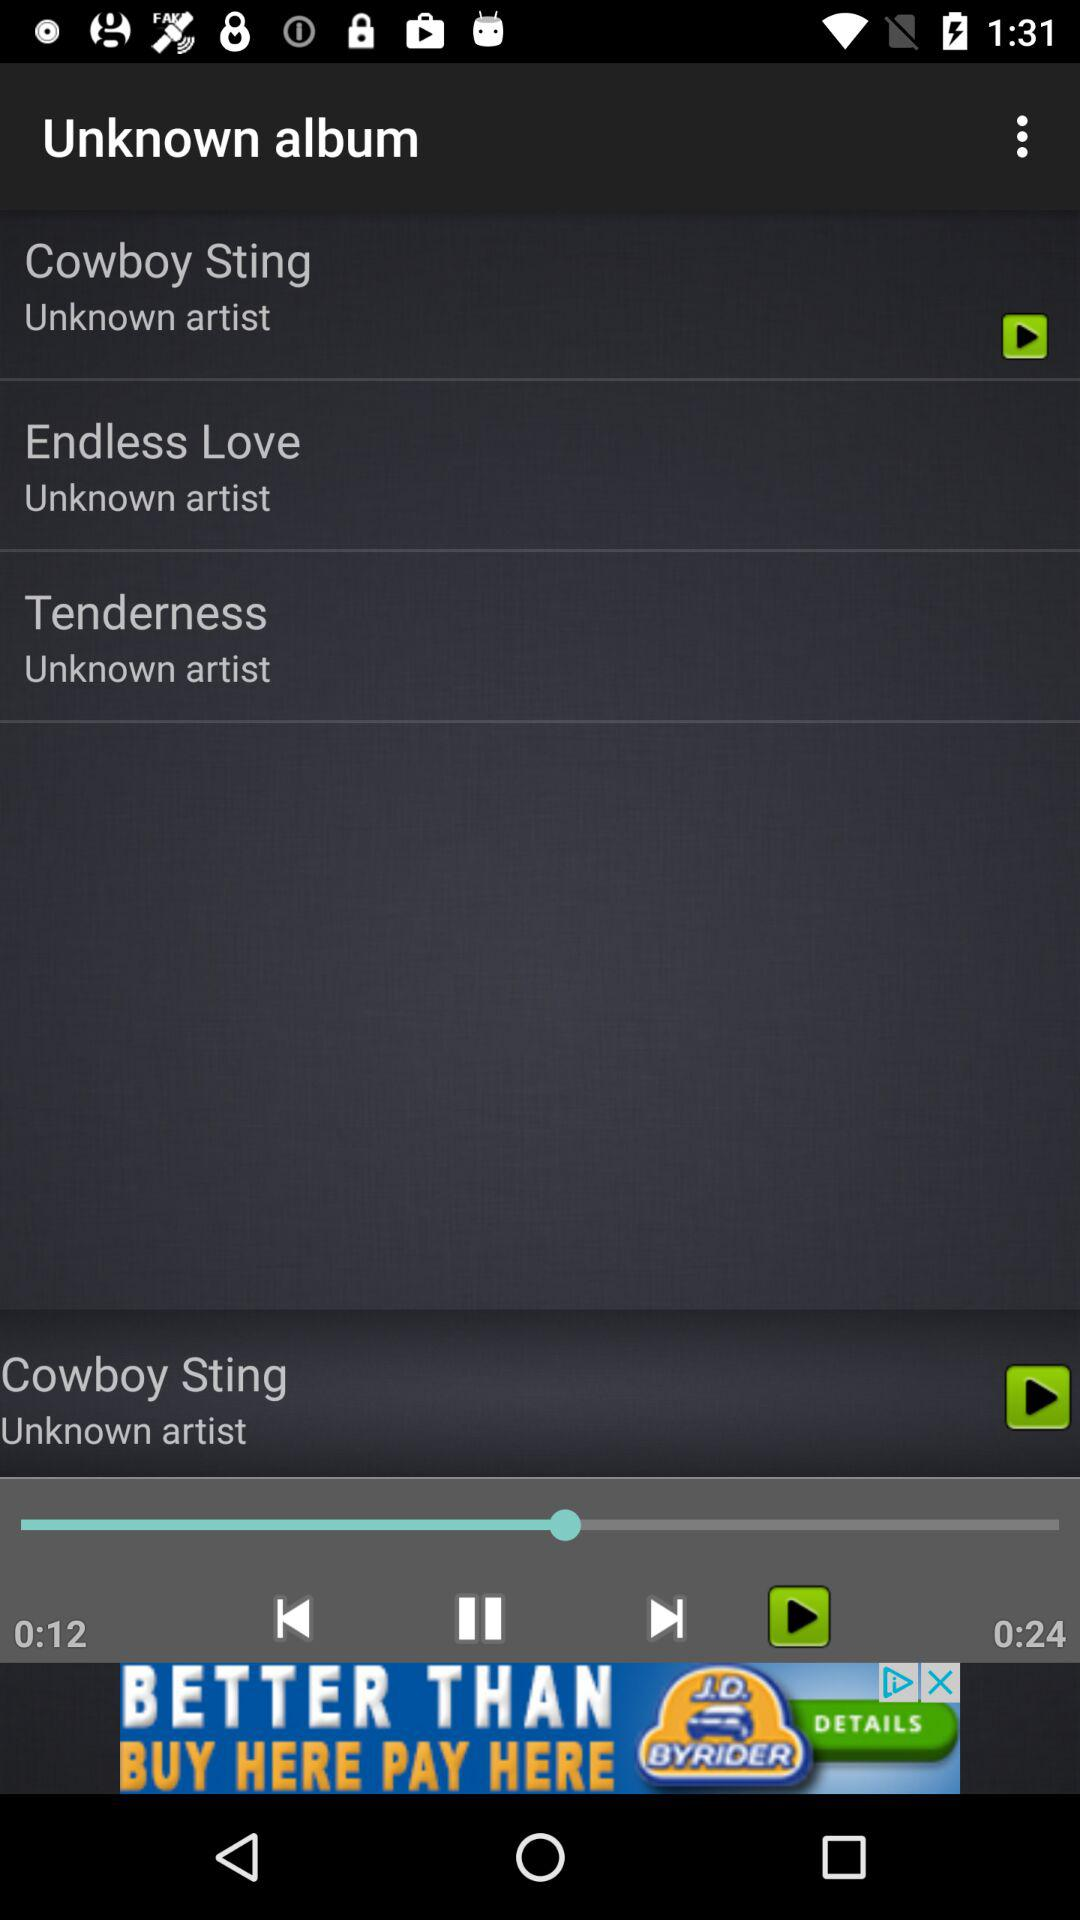How long has the song lasted? The song has lasted for 12 seconds. 